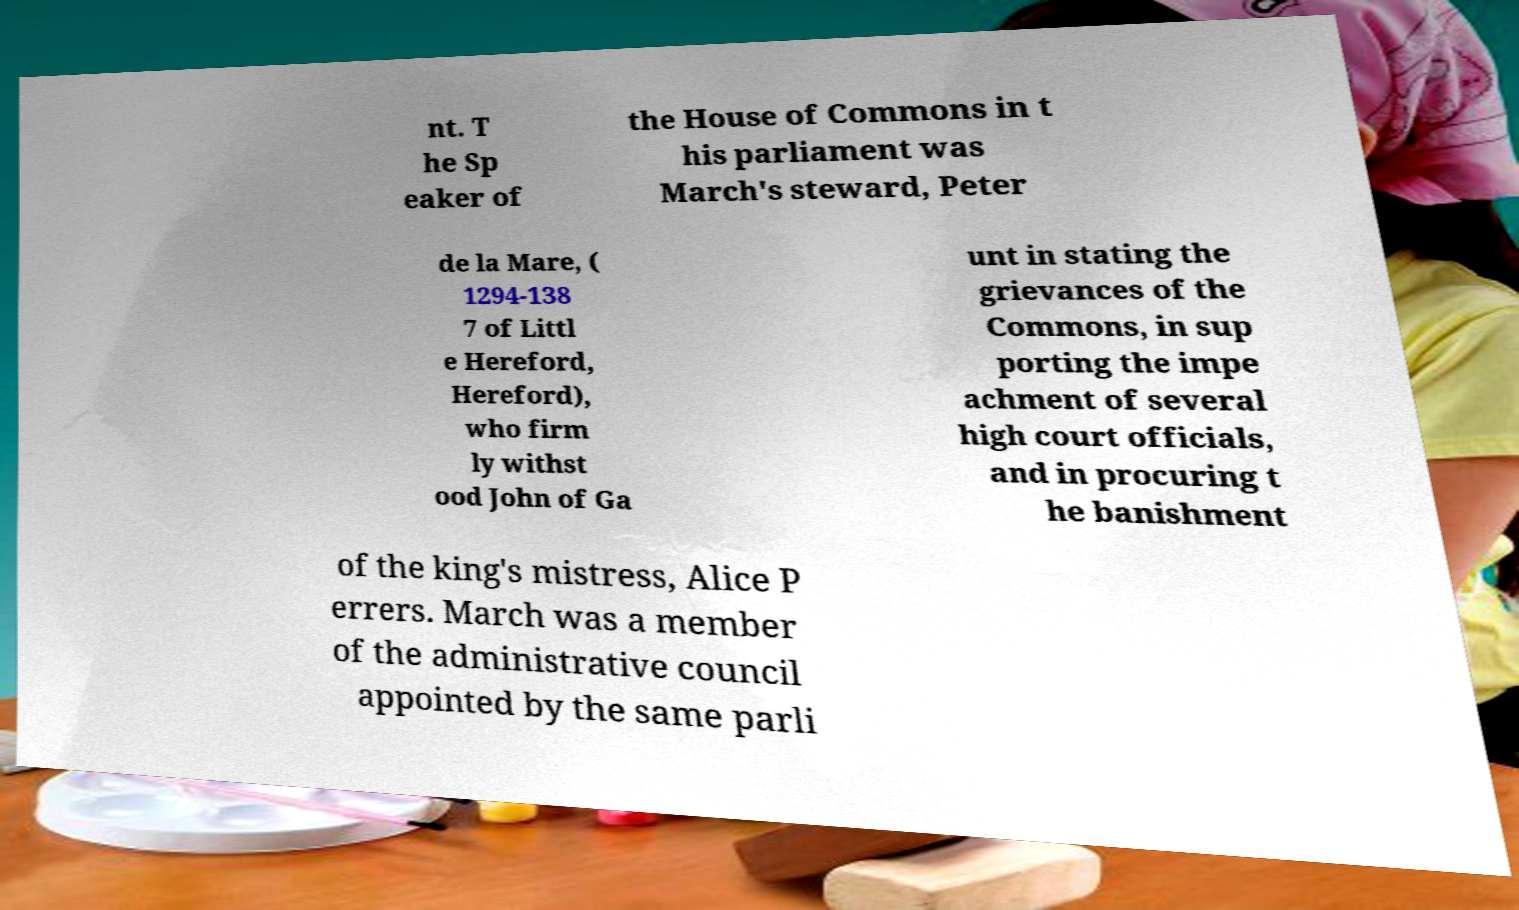Could you assist in decoding the text presented in this image and type it out clearly? nt. T he Sp eaker of the House of Commons in t his parliament was March's steward, Peter de la Mare, ( 1294-138 7 of Littl e Hereford, Hereford), who firm ly withst ood John of Ga unt in stating the grievances of the Commons, in sup porting the impe achment of several high court officials, and in procuring t he banishment of the king's mistress, Alice P errers. March was a member of the administrative council appointed by the same parli 